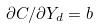Convert formula to latex. <formula><loc_0><loc_0><loc_500><loc_500>\partial C / \partial Y _ { d } = b</formula> 